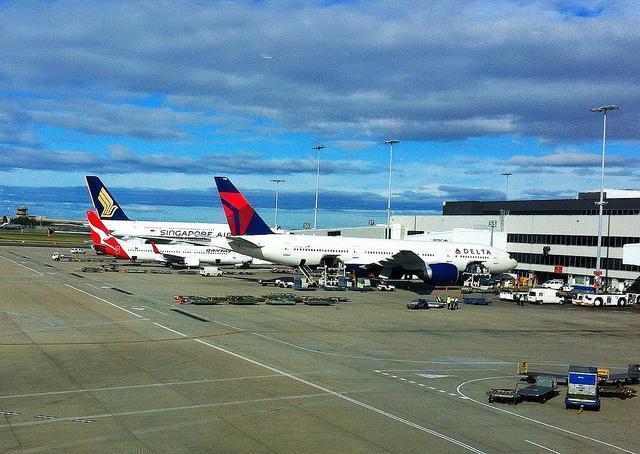How many different airlines are being featured by the planes in the photo?
Indicate the correct response by choosing from the four available options to answer the question.
Options: One, two, three, four. Three. 